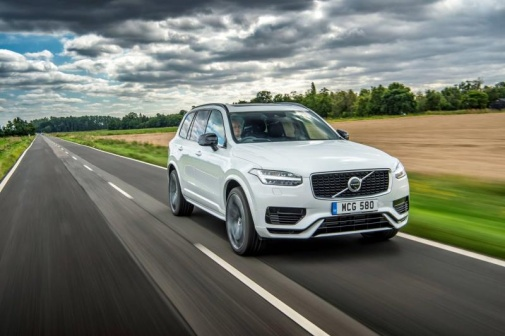What if this scene was during a foggy morning? During a foggy morning, this scene transforms into a mysterious yet enchanting setting. The white Volvo XC90 SUV moves cautiously through the dense fog that blankets the highway, reducing visibility and adding an air of intrigue. The green fields and trees on either side appear as shadowy forms, barely visible through the mist. The fog softens all sounds, creating an almost eerie silence interrupted only by the gentle hum of the SUV's engine. The wet road glistens as it reflects the soft glow of the car's headlights cutting through the haze, making the drive a contemplative and almost surreal experience. 